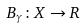Convert formula to latex. <formula><loc_0><loc_0><loc_500><loc_500>B _ { \gamma } \colon X \rightarrow R</formula> 